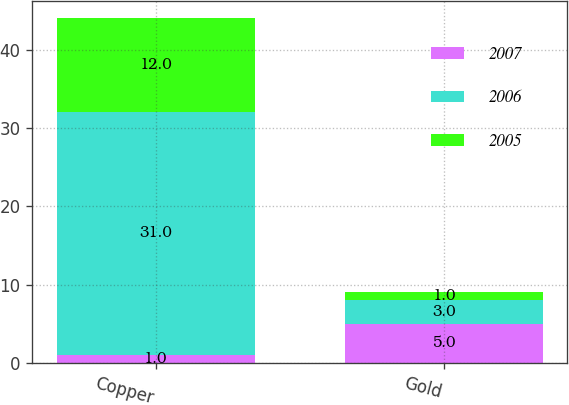<chart> <loc_0><loc_0><loc_500><loc_500><stacked_bar_chart><ecel><fcel>Copper<fcel>Gold<nl><fcel>2007<fcel>1<fcel>5<nl><fcel>2006<fcel>31<fcel>3<nl><fcel>2005<fcel>12<fcel>1<nl></chart> 